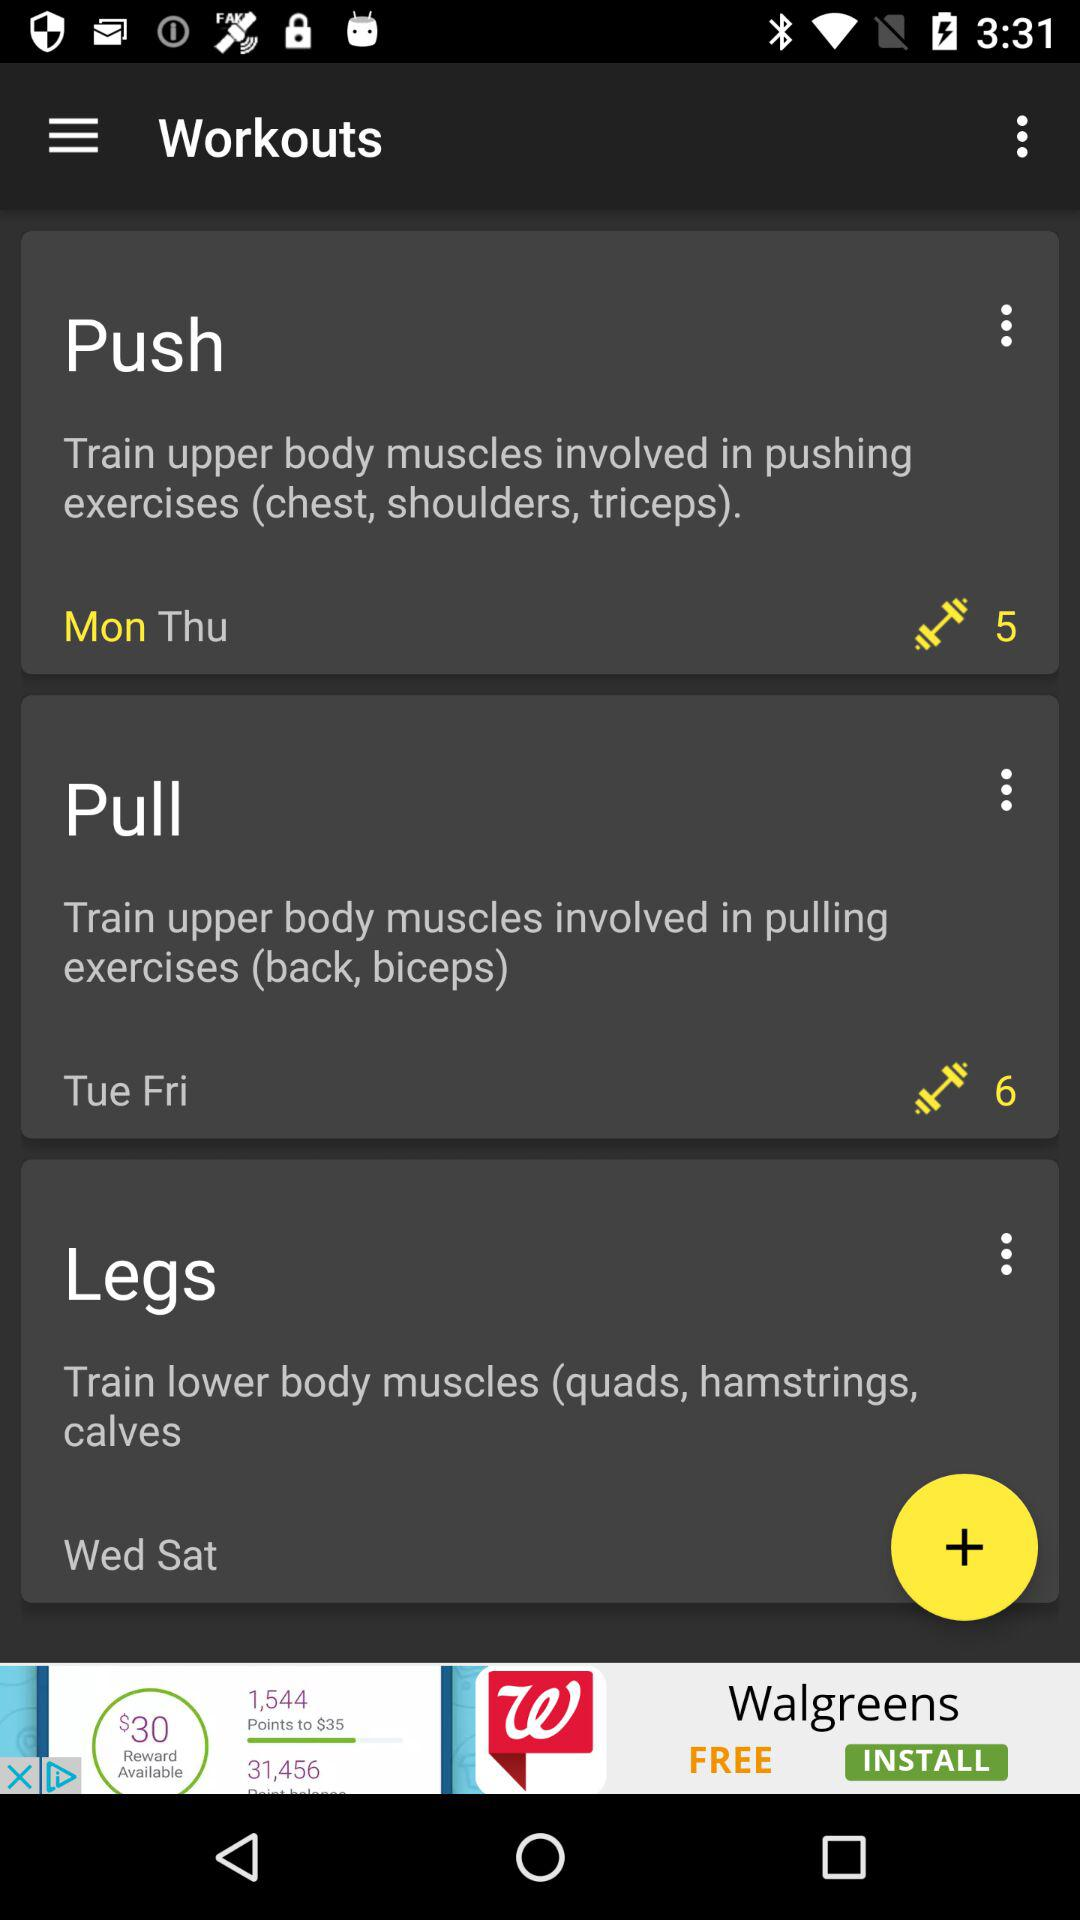How many dumbbells are there for push-ups?
When the provided information is insufficient, respond with <no answer>. <no answer> 